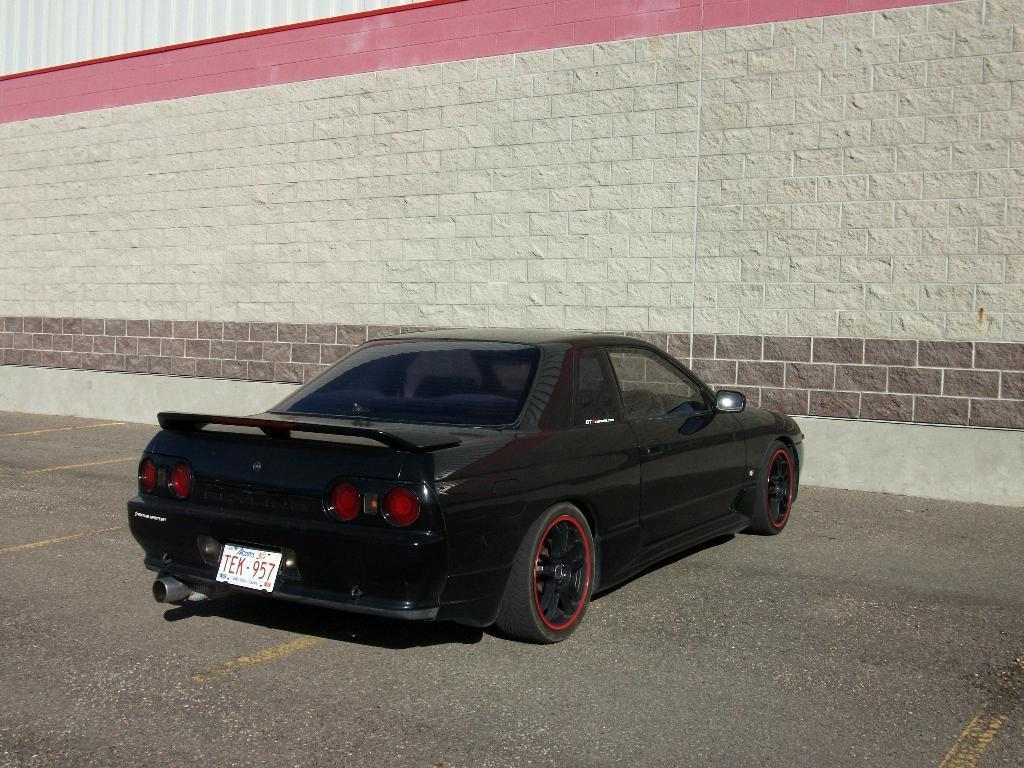Please provide a concise description of this image. In the foreground of this image, we see a car parked on ground and in the background, we see a wall. 